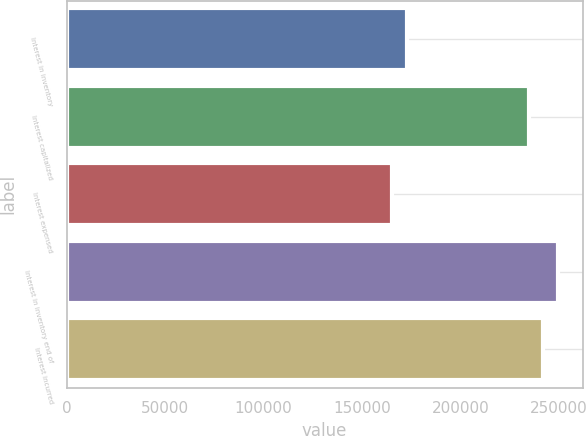Convert chart. <chart><loc_0><loc_0><loc_500><loc_500><bar_chart><fcel>Interest in inventory<fcel>Interest capitalized<fcel>Interest expensed<fcel>Interest in inventory end of<fcel>Interest incurred<nl><fcel>172756<fcel>234700<fcel>165355<fcel>249502<fcel>242101<nl></chart> 